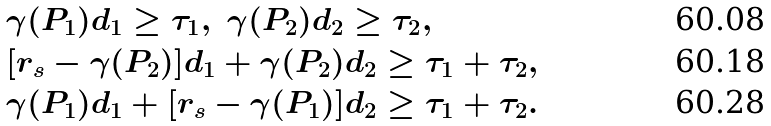Convert formula to latex. <formula><loc_0><loc_0><loc_500><loc_500>& \gamma ( P _ { 1 } ) d _ { 1 } \geq \tau _ { 1 } , \ \gamma ( P _ { 2 } ) d _ { 2 } \geq \tau _ { 2 } , \\ & [ r _ { s } - \gamma ( P _ { 2 } ) ] d _ { 1 } + \gamma ( P _ { 2 } ) d _ { 2 } \geq \tau _ { 1 } + \tau _ { 2 } , \\ & \gamma ( P _ { 1 } ) d _ { 1 } + [ r _ { s } - \gamma ( P _ { 1 } ) ] d _ { 2 } \geq \tau _ { 1 } + \tau _ { 2 } .</formula> 